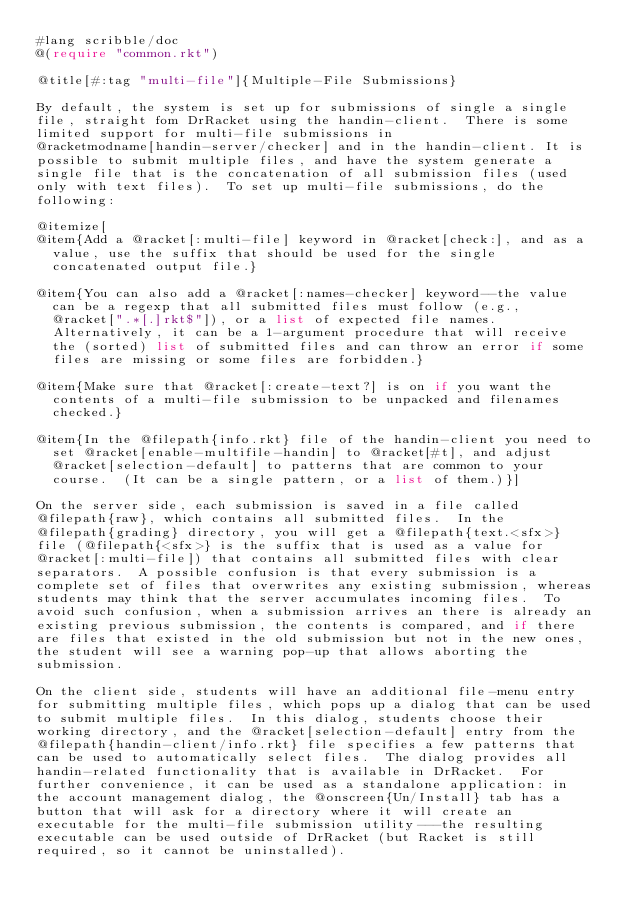Convert code to text. <code><loc_0><loc_0><loc_500><loc_500><_Racket_>#lang scribble/doc
@(require "common.rkt")

@title[#:tag "multi-file"]{Multiple-File Submissions}

By default, the system is set up for submissions of single a single
file, straight fom DrRacket using the handin-client.  There is some
limited support for multi-file submissions in
@racketmodname[handin-server/checker] and in the handin-client. It is
possible to submit multiple files, and have the system generate a
single file that is the concatenation of all submission files (used
only with text files).  To set up multi-file submissions, do the
following:

@itemize[
@item{Add a @racket[:multi-file] keyword in @racket[check:], and as a
  value, use the suffix that should be used for the single
  concatenated output file.}

@item{You can also add a @racket[:names-checker] keyword--the value
  can be a regexp that all submitted files must follow (e.g.,
  @racket[".*[.]rkt$"]), or a list of expected file names.
  Alternatively, it can be a 1-argument procedure that will receive
  the (sorted) list of submitted files and can throw an error if some
  files are missing or some files are forbidden.}

@item{Make sure that @racket[:create-text?] is on if you want the
  contents of a multi-file submission to be unpacked and filenames
  checked.}

@item{In the @filepath{info.rkt} file of the handin-client you need to
  set @racket[enable-multifile-handin] to @racket[#t], and adjust
  @racket[selection-default] to patterns that are common to your
  course.  (It can be a single pattern, or a list of them.)}]

On the server side, each submission is saved in a file called
@filepath{raw}, which contains all submitted files.  In the
@filepath{grading} directory, you will get a @filepath{text.<sfx>}
file (@filepath{<sfx>} is the suffix that is used as a value for
@racket[:multi-file]) that contains all submitted files with clear
separators.  A possible confusion is that every submission is a
complete set of files that overwrites any existing submission, whereas
students may think that the server accumulates incoming files.  To
avoid such confusion, when a submission arrives an there is already an
existing previous submission, the contents is compared, and if there
are files that existed in the old submission but not in the new ones,
the student will see a warning pop-up that allows aborting the
submission.

On the client side, students will have an additional file-menu entry
for submitting multiple files, which pops up a dialog that can be used
to submit multiple files.  In this dialog, students choose their
working directory, and the @racket[selection-default] entry from the
@filepath{handin-client/info.rkt} file specifies a few patterns that
can be used to automatically select files.  The dialog provides all
handin-related functionality that is available in DrRacket.  For
further convenience, it can be used as a standalone application: in
the account management dialog, the @onscreen{Un/Install} tab has a
button that will ask for a directory where it will create an
executable for the multi-file submission utility---the resulting
executable can be used outside of DrRacket (but Racket is still
required, so it cannot be uninstalled).
</code> 